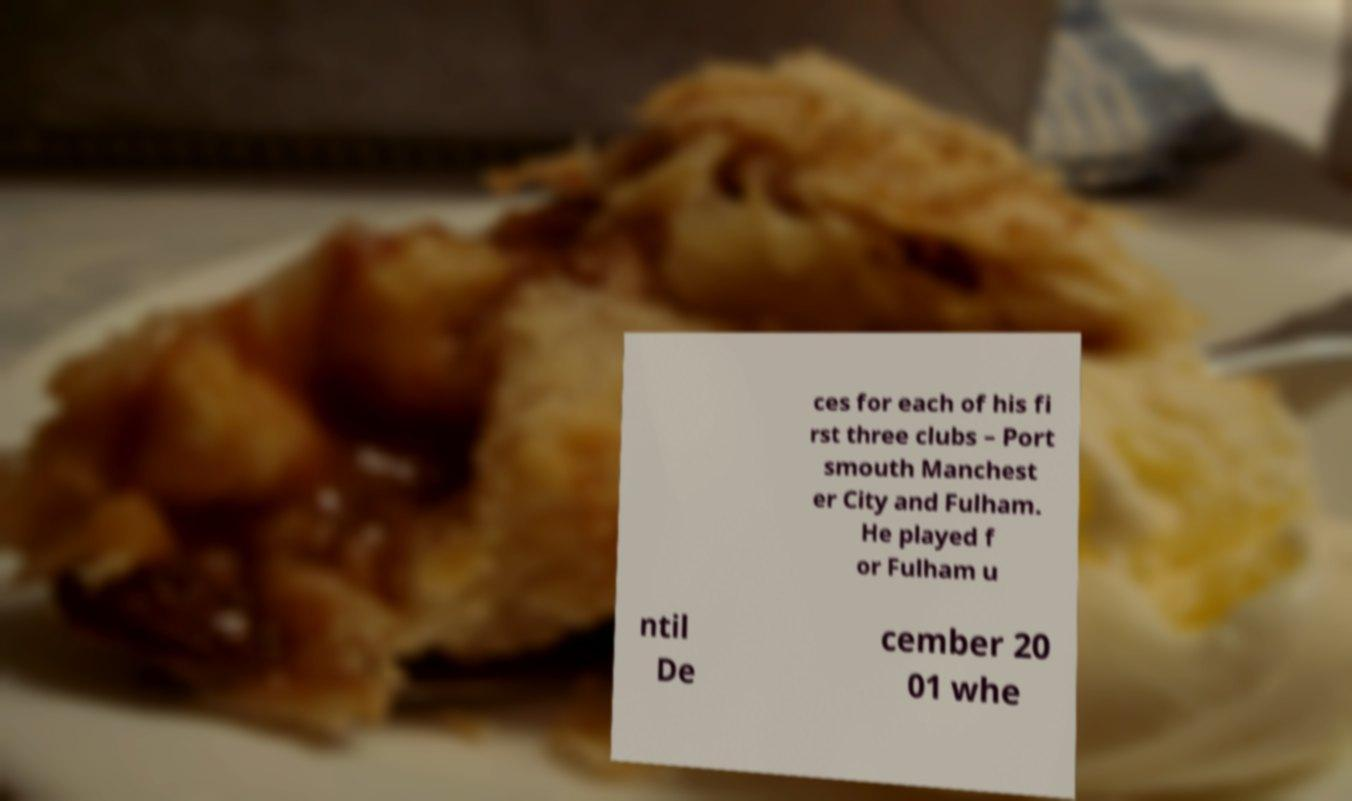What messages or text are displayed in this image? I need them in a readable, typed format. ces for each of his fi rst three clubs – Port smouth Manchest er City and Fulham. He played f or Fulham u ntil De cember 20 01 whe 